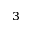<formula> <loc_0><loc_0><loc_500><loc_500>^ { 3 }</formula> 